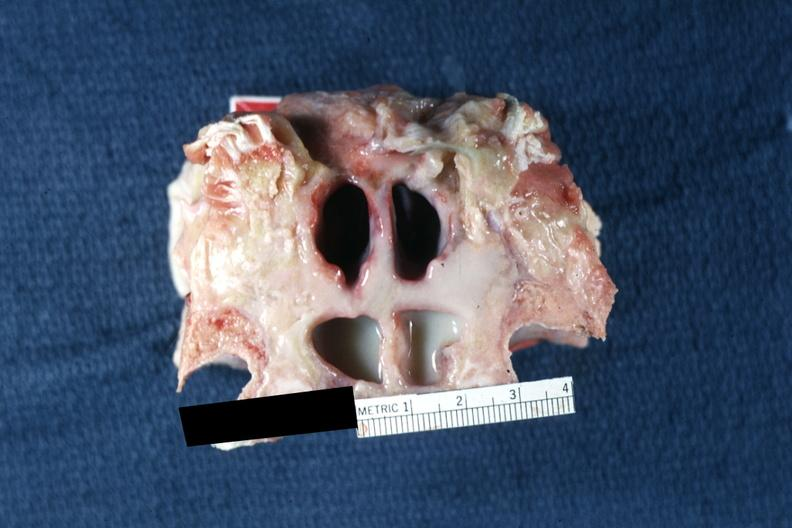does this image show frontal sinuses inflammation and pus well shown?
Answer the question using a single word or phrase. Yes 